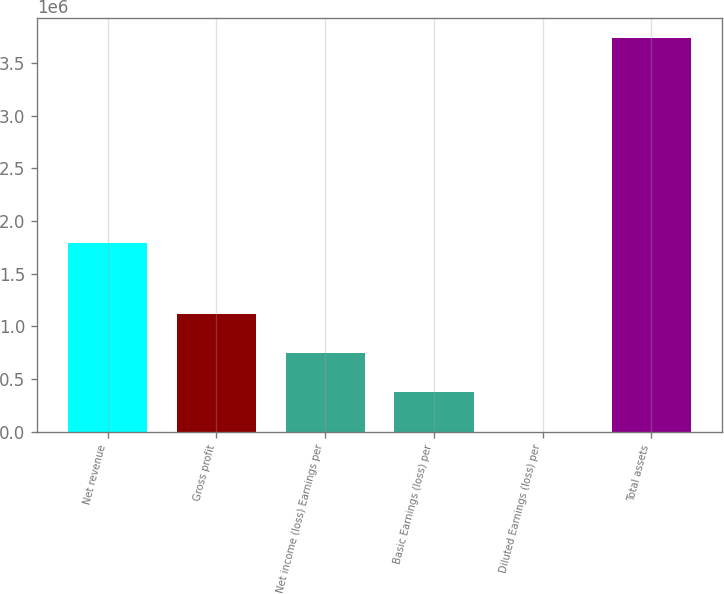Convert chart to OTSL. <chart><loc_0><loc_0><loc_500><loc_500><bar_chart><fcel>Net revenue<fcel>Gross profit<fcel>Net income (loss) Earnings per<fcel>Basic Earnings (loss) per<fcel>Diluted Earnings (loss) per<fcel>Total assets<nl><fcel>1.79289e+06<fcel>1.12135e+06<fcel>747569<fcel>373785<fcel>1.54<fcel>3.73784e+06<nl></chart> 